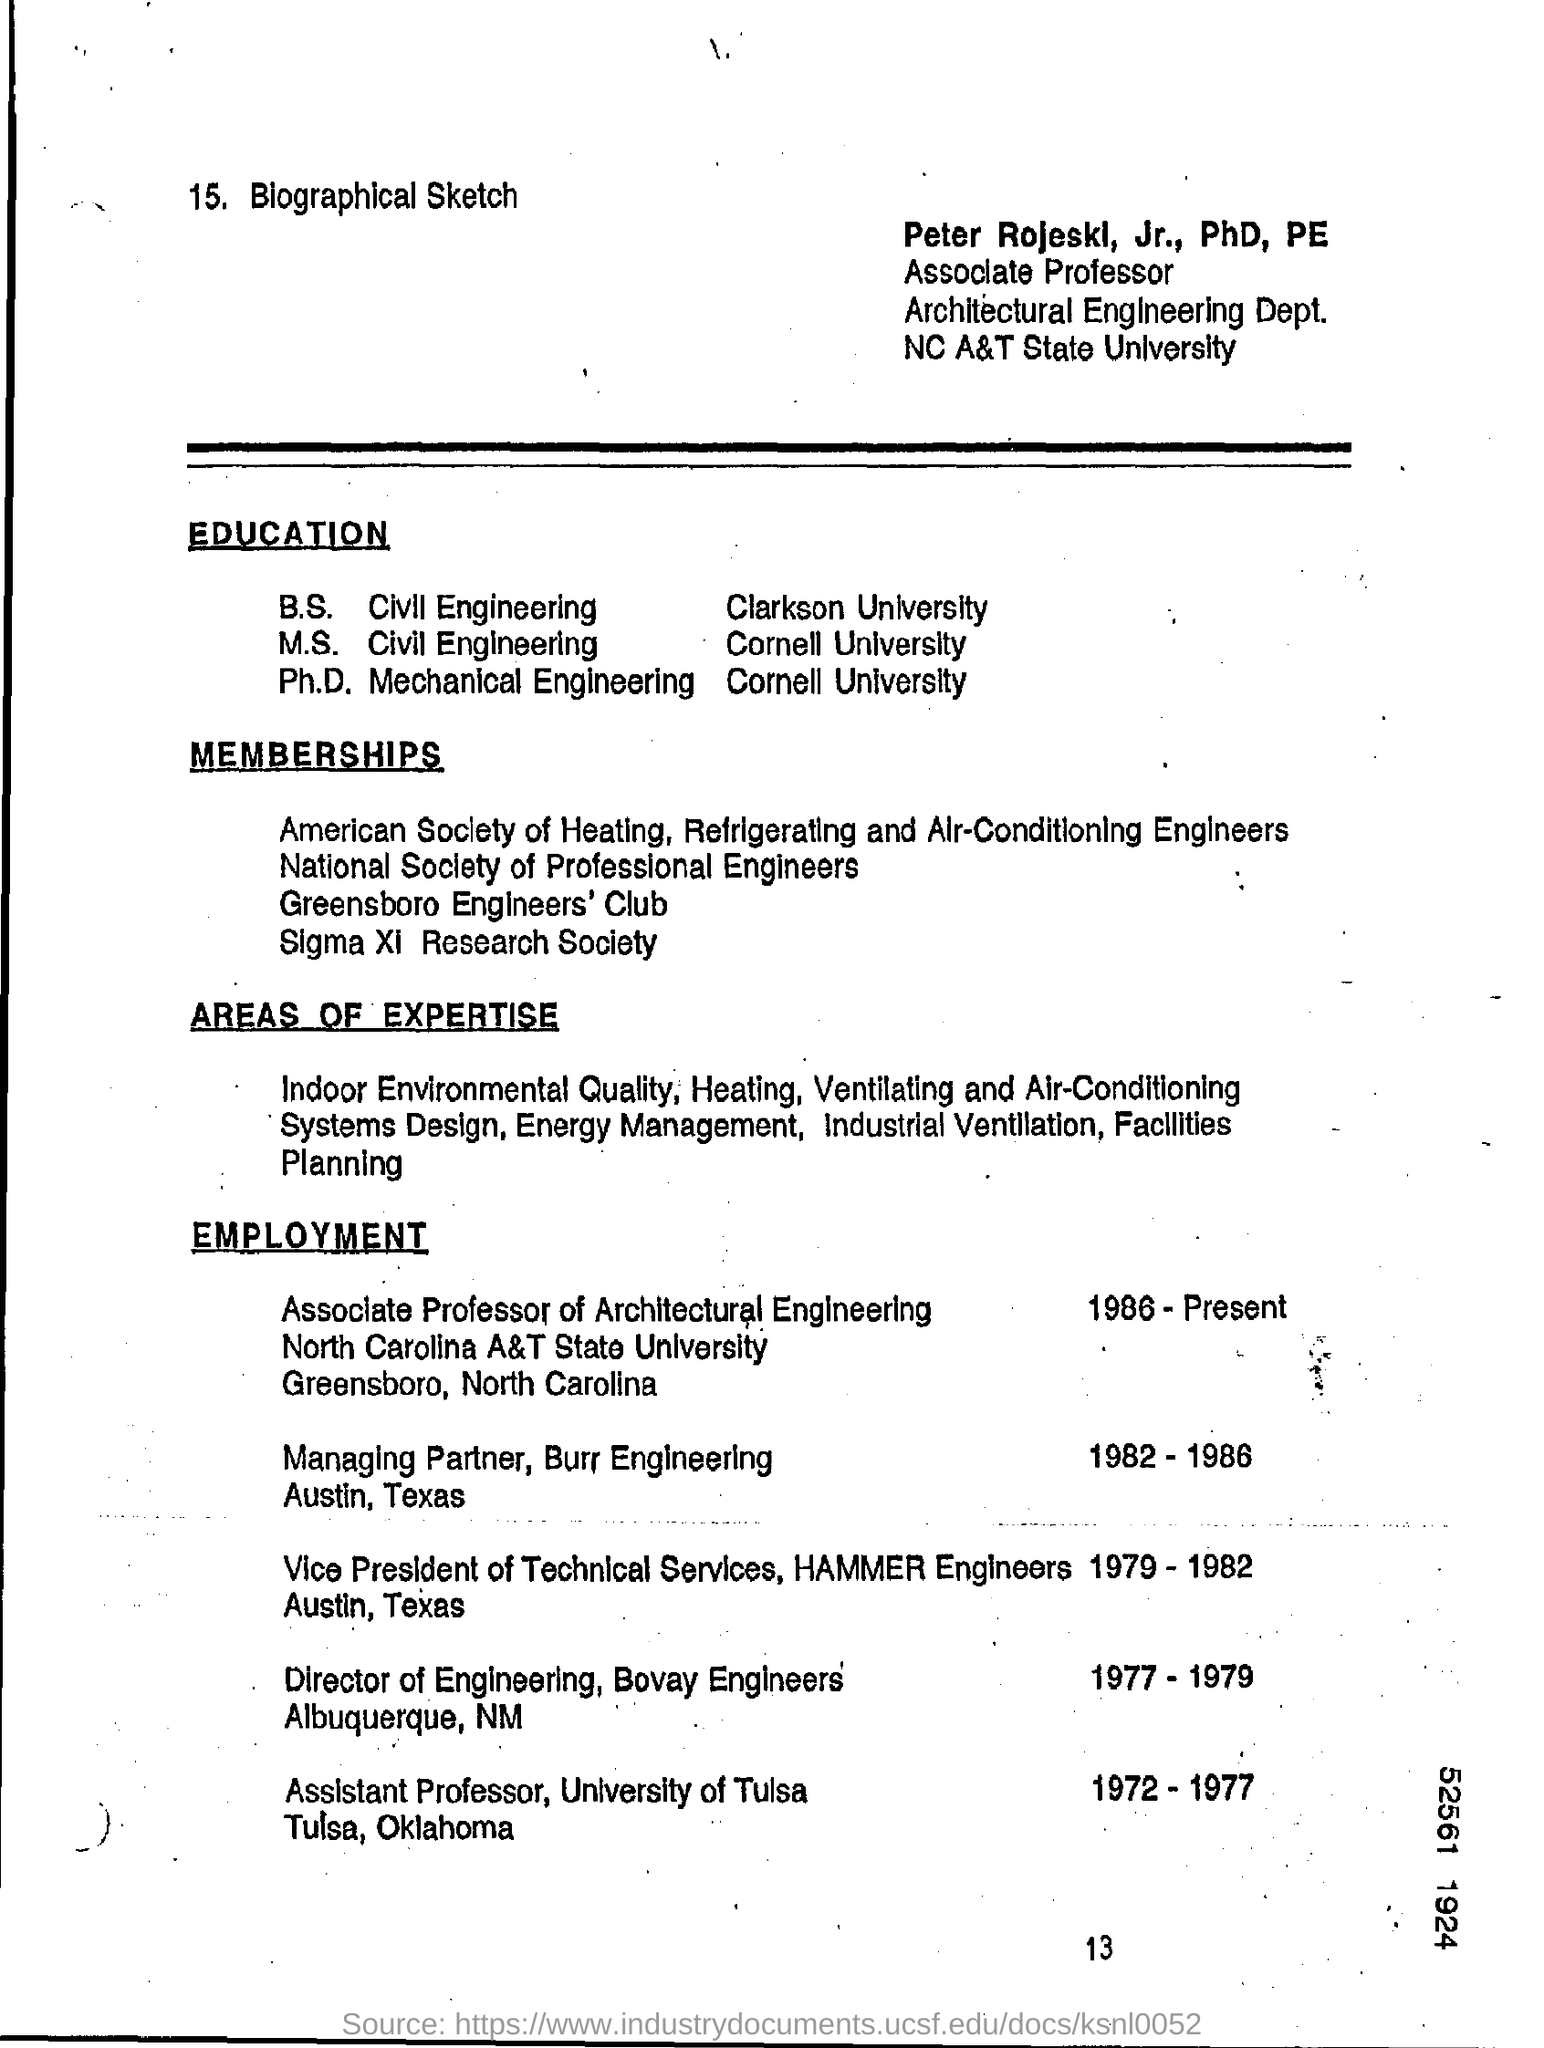What is the position of peter rojeskl, jr., phd, pe?
Give a very brief answer. Associate professor. From which university did peter rojeskl complete his ph.d.  ?
Keep it short and to the point. Cornell university. 